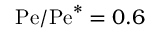<formula> <loc_0><loc_0><loc_500><loc_500>P e / P e ^ { * } = 0 . 6</formula> 